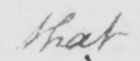Can you read and transcribe this handwriting? that 